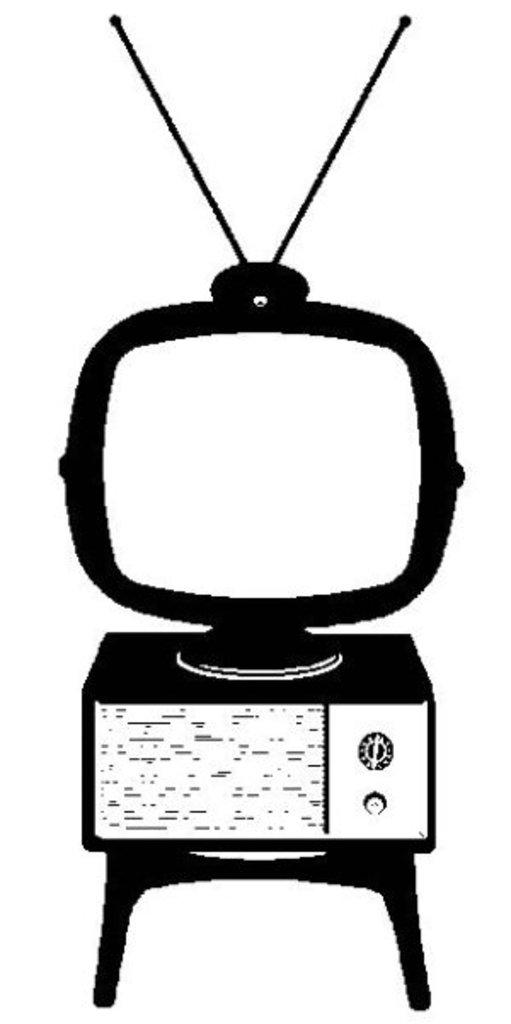What electronic device is present in the image? There is a television in the image. How is the television positioned in the image? The television is placed on a device. What type of furniture is visible in the image? There is a stool in the image. What type of stone can be seen on the library shelves in the image? There is no stone or library present in the image; it features a television placed on a device and a stool. 